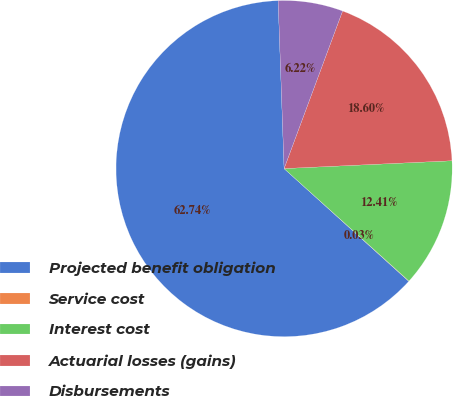Convert chart. <chart><loc_0><loc_0><loc_500><loc_500><pie_chart><fcel>Projected benefit obligation<fcel>Service cost<fcel>Interest cost<fcel>Actuarial losses (gains)<fcel>Disbursements<nl><fcel>62.73%<fcel>0.03%<fcel>12.41%<fcel>18.6%<fcel>6.22%<nl></chart> 